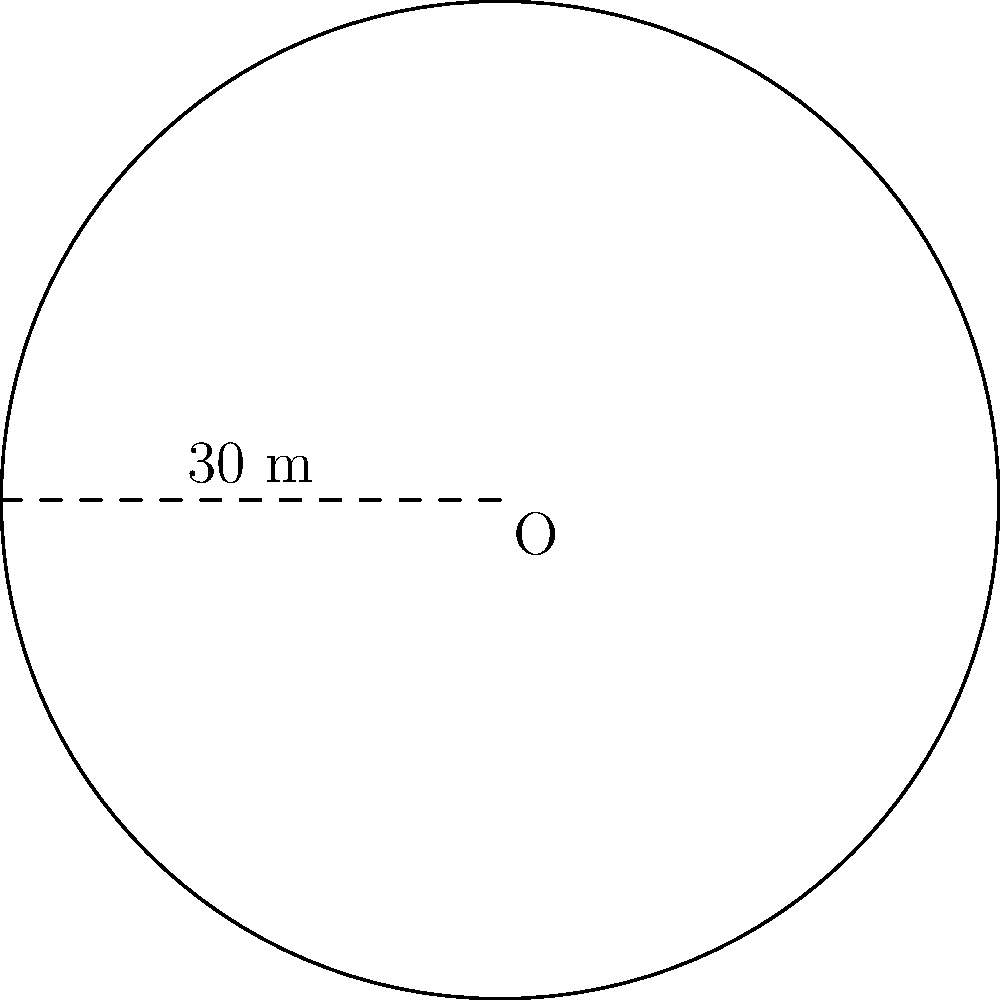A retirement community is planning to install a circular walking path in their garden. If the radius of the path is 30 meters, what is the approximate length of the entire path? Round your answer to the nearest meter. To solve this problem, we need to calculate the circumference of the circular path. Let's break it down step-by-step:

1. Recall the formula for the circumference of a circle:
   $$C = 2\pi r$$
   where $C$ is the circumference and $r$ is the radius.

2. We are given that the radius is 30 meters.

3. Let's substitute this into our formula:
   $$C = 2\pi (30)$$

4. Simplify:
   $$C = 60\pi$$

5. Now, let's calculate this value:
   $$C \approx 60 \times 3.14159 = 188.4954 \text{ meters}$$

6. Rounding to the nearest meter:
   $$C \approx 188 \text{ meters}$$

Therefore, the approximate length of the entire circular walking path is 188 meters.
Answer: 188 meters 